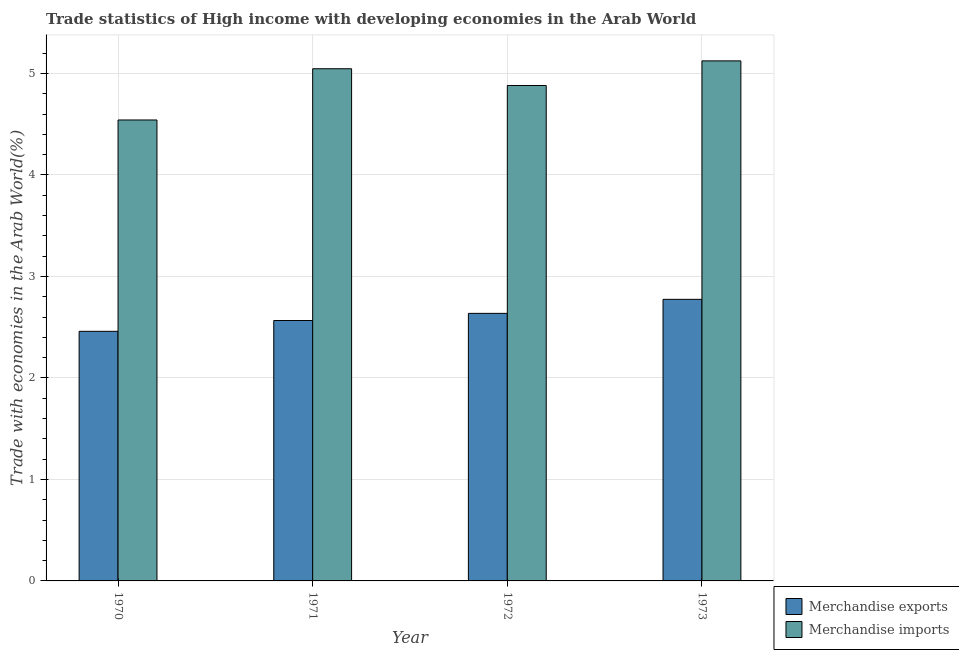What is the label of the 3rd group of bars from the left?
Your answer should be compact. 1972. What is the merchandise imports in 1973?
Your answer should be very brief. 5.12. Across all years, what is the maximum merchandise exports?
Offer a terse response. 2.77. Across all years, what is the minimum merchandise exports?
Make the answer very short. 2.46. In which year was the merchandise exports maximum?
Give a very brief answer. 1973. In which year was the merchandise imports minimum?
Offer a very short reply. 1970. What is the total merchandise exports in the graph?
Keep it short and to the point. 10.44. What is the difference between the merchandise imports in 1972 and that in 1973?
Your response must be concise. -0.24. What is the difference between the merchandise exports in 1972 and the merchandise imports in 1970?
Offer a very short reply. 0.18. What is the average merchandise imports per year?
Offer a terse response. 4.9. What is the ratio of the merchandise exports in 1972 to that in 1973?
Make the answer very short. 0.95. Is the difference between the merchandise exports in 1970 and 1971 greater than the difference between the merchandise imports in 1970 and 1971?
Your answer should be compact. No. What is the difference between the highest and the second highest merchandise exports?
Offer a very short reply. 0.14. What is the difference between the highest and the lowest merchandise exports?
Your response must be concise. 0.32. Is the sum of the merchandise imports in 1970 and 1973 greater than the maximum merchandise exports across all years?
Ensure brevity in your answer.  Yes. What does the 1st bar from the left in 1970 represents?
Offer a very short reply. Merchandise exports. How many bars are there?
Offer a very short reply. 8. Are all the bars in the graph horizontal?
Provide a succinct answer. No. How many years are there in the graph?
Your response must be concise. 4. What is the difference between two consecutive major ticks on the Y-axis?
Provide a succinct answer. 1. Are the values on the major ticks of Y-axis written in scientific E-notation?
Make the answer very short. No. How many legend labels are there?
Keep it short and to the point. 2. What is the title of the graph?
Offer a terse response. Trade statistics of High income with developing economies in the Arab World. What is the label or title of the X-axis?
Offer a terse response. Year. What is the label or title of the Y-axis?
Your answer should be compact. Trade with economies in the Arab World(%). What is the Trade with economies in the Arab World(%) of Merchandise exports in 1970?
Make the answer very short. 2.46. What is the Trade with economies in the Arab World(%) of Merchandise imports in 1970?
Offer a very short reply. 4.54. What is the Trade with economies in the Arab World(%) of Merchandise exports in 1971?
Offer a terse response. 2.57. What is the Trade with economies in the Arab World(%) of Merchandise imports in 1971?
Your answer should be compact. 5.05. What is the Trade with economies in the Arab World(%) in Merchandise exports in 1972?
Offer a very short reply. 2.64. What is the Trade with economies in the Arab World(%) of Merchandise imports in 1972?
Keep it short and to the point. 4.88. What is the Trade with economies in the Arab World(%) of Merchandise exports in 1973?
Provide a short and direct response. 2.77. What is the Trade with economies in the Arab World(%) in Merchandise imports in 1973?
Offer a very short reply. 5.12. Across all years, what is the maximum Trade with economies in the Arab World(%) in Merchandise exports?
Offer a very short reply. 2.77. Across all years, what is the maximum Trade with economies in the Arab World(%) of Merchandise imports?
Make the answer very short. 5.12. Across all years, what is the minimum Trade with economies in the Arab World(%) of Merchandise exports?
Your answer should be compact. 2.46. Across all years, what is the minimum Trade with economies in the Arab World(%) of Merchandise imports?
Your answer should be compact. 4.54. What is the total Trade with economies in the Arab World(%) in Merchandise exports in the graph?
Make the answer very short. 10.44. What is the total Trade with economies in the Arab World(%) of Merchandise imports in the graph?
Ensure brevity in your answer.  19.59. What is the difference between the Trade with economies in the Arab World(%) of Merchandise exports in 1970 and that in 1971?
Ensure brevity in your answer.  -0.11. What is the difference between the Trade with economies in the Arab World(%) of Merchandise imports in 1970 and that in 1971?
Make the answer very short. -0.5. What is the difference between the Trade with economies in the Arab World(%) of Merchandise exports in 1970 and that in 1972?
Make the answer very short. -0.18. What is the difference between the Trade with economies in the Arab World(%) of Merchandise imports in 1970 and that in 1972?
Make the answer very short. -0.34. What is the difference between the Trade with economies in the Arab World(%) of Merchandise exports in 1970 and that in 1973?
Keep it short and to the point. -0.32. What is the difference between the Trade with economies in the Arab World(%) of Merchandise imports in 1970 and that in 1973?
Your response must be concise. -0.58. What is the difference between the Trade with economies in the Arab World(%) of Merchandise exports in 1971 and that in 1972?
Make the answer very short. -0.07. What is the difference between the Trade with economies in the Arab World(%) of Merchandise imports in 1971 and that in 1972?
Offer a terse response. 0.17. What is the difference between the Trade with economies in the Arab World(%) in Merchandise exports in 1971 and that in 1973?
Ensure brevity in your answer.  -0.21. What is the difference between the Trade with economies in the Arab World(%) of Merchandise imports in 1971 and that in 1973?
Keep it short and to the point. -0.08. What is the difference between the Trade with economies in the Arab World(%) in Merchandise exports in 1972 and that in 1973?
Give a very brief answer. -0.14. What is the difference between the Trade with economies in the Arab World(%) of Merchandise imports in 1972 and that in 1973?
Ensure brevity in your answer.  -0.24. What is the difference between the Trade with economies in the Arab World(%) of Merchandise exports in 1970 and the Trade with economies in the Arab World(%) of Merchandise imports in 1971?
Ensure brevity in your answer.  -2.59. What is the difference between the Trade with economies in the Arab World(%) in Merchandise exports in 1970 and the Trade with economies in the Arab World(%) in Merchandise imports in 1972?
Make the answer very short. -2.42. What is the difference between the Trade with economies in the Arab World(%) in Merchandise exports in 1970 and the Trade with economies in the Arab World(%) in Merchandise imports in 1973?
Offer a very short reply. -2.66. What is the difference between the Trade with economies in the Arab World(%) in Merchandise exports in 1971 and the Trade with economies in the Arab World(%) in Merchandise imports in 1972?
Your answer should be compact. -2.32. What is the difference between the Trade with economies in the Arab World(%) in Merchandise exports in 1971 and the Trade with economies in the Arab World(%) in Merchandise imports in 1973?
Your answer should be compact. -2.56. What is the difference between the Trade with economies in the Arab World(%) of Merchandise exports in 1972 and the Trade with economies in the Arab World(%) of Merchandise imports in 1973?
Ensure brevity in your answer.  -2.49. What is the average Trade with economies in the Arab World(%) in Merchandise exports per year?
Offer a very short reply. 2.61. What is the average Trade with economies in the Arab World(%) of Merchandise imports per year?
Give a very brief answer. 4.9. In the year 1970, what is the difference between the Trade with economies in the Arab World(%) of Merchandise exports and Trade with economies in the Arab World(%) of Merchandise imports?
Give a very brief answer. -2.08. In the year 1971, what is the difference between the Trade with economies in the Arab World(%) of Merchandise exports and Trade with economies in the Arab World(%) of Merchandise imports?
Keep it short and to the point. -2.48. In the year 1972, what is the difference between the Trade with economies in the Arab World(%) of Merchandise exports and Trade with economies in the Arab World(%) of Merchandise imports?
Give a very brief answer. -2.25. In the year 1973, what is the difference between the Trade with economies in the Arab World(%) of Merchandise exports and Trade with economies in the Arab World(%) of Merchandise imports?
Your answer should be very brief. -2.35. What is the ratio of the Trade with economies in the Arab World(%) in Merchandise exports in 1970 to that in 1971?
Make the answer very short. 0.96. What is the ratio of the Trade with economies in the Arab World(%) of Merchandise exports in 1970 to that in 1972?
Keep it short and to the point. 0.93. What is the ratio of the Trade with economies in the Arab World(%) in Merchandise imports in 1970 to that in 1972?
Offer a very short reply. 0.93. What is the ratio of the Trade with economies in the Arab World(%) of Merchandise exports in 1970 to that in 1973?
Offer a very short reply. 0.89. What is the ratio of the Trade with economies in the Arab World(%) of Merchandise imports in 1970 to that in 1973?
Keep it short and to the point. 0.89. What is the ratio of the Trade with economies in the Arab World(%) of Merchandise exports in 1971 to that in 1972?
Ensure brevity in your answer.  0.97. What is the ratio of the Trade with economies in the Arab World(%) in Merchandise imports in 1971 to that in 1972?
Ensure brevity in your answer.  1.03. What is the ratio of the Trade with economies in the Arab World(%) of Merchandise exports in 1971 to that in 1973?
Your response must be concise. 0.92. What is the ratio of the Trade with economies in the Arab World(%) in Merchandise imports in 1971 to that in 1973?
Give a very brief answer. 0.98. What is the ratio of the Trade with economies in the Arab World(%) of Merchandise exports in 1972 to that in 1973?
Offer a terse response. 0.95. What is the ratio of the Trade with economies in the Arab World(%) in Merchandise imports in 1972 to that in 1973?
Make the answer very short. 0.95. What is the difference between the highest and the second highest Trade with economies in the Arab World(%) in Merchandise exports?
Keep it short and to the point. 0.14. What is the difference between the highest and the second highest Trade with economies in the Arab World(%) of Merchandise imports?
Provide a short and direct response. 0.08. What is the difference between the highest and the lowest Trade with economies in the Arab World(%) in Merchandise exports?
Keep it short and to the point. 0.32. What is the difference between the highest and the lowest Trade with economies in the Arab World(%) of Merchandise imports?
Give a very brief answer. 0.58. 